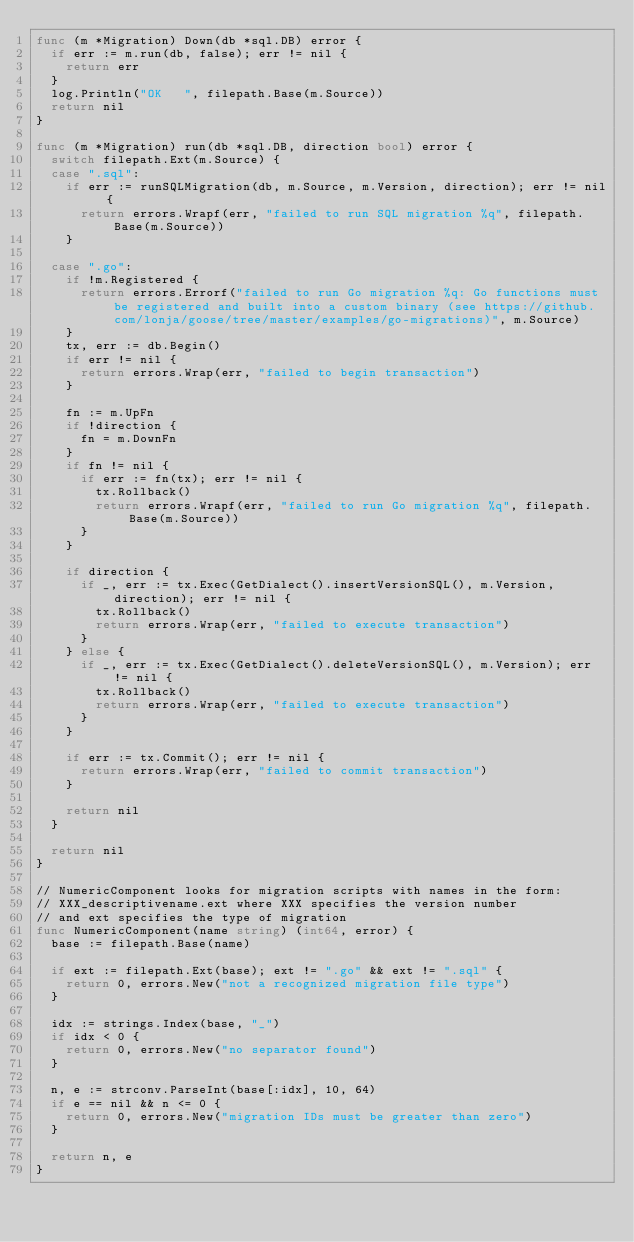Convert code to text. <code><loc_0><loc_0><loc_500><loc_500><_Go_>func (m *Migration) Down(db *sql.DB) error {
	if err := m.run(db, false); err != nil {
		return err
	}
	log.Println("OK   ", filepath.Base(m.Source))
	return nil
}

func (m *Migration) run(db *sql.DB, direction bool) error {
	switch filepath.Ext(m.Source) {
	case ".sql":
		if err := runSQLMigration(db, m.Source, m.Version, direction); err != nil {
			return errors.Wrapf(err, "failed to run SQL migration %q", filepath.Base(m.Source))
		}

	case ".go":
		if !m.Registered {
			return errors.Errorf("failed to run Go migration %q: Go functions must be registered and built into a custom binary (see https://github.com/lonja/goose/tree/master/examples/go-migrations)", m.Source)
		}
		tx, err := db.Begin()
		if err != nil {
			return errors.Wrap(err, "failed to begin transaction")
		}

		fn := m.UpFn
		if !direction {
			fn = m.DownFn
		}
		if fn != nil {
			if err := fn(tx); err != nil {
				tx.Rollback()
				return errors.Wrapf(err, "failed to run Go migration %q", filepath.Base(m.Source))
			}
		}

		if direction {
			if _, err := tx.Exec(GetDialect().insertVersionSQL(), m.Version, direction); err != nil {
				tx.Rollback()
				return errors.Wrap(err, "failed to execute transaction")
			}
		} else {
			if _, err := tx.Exec(GetDialect().deleteVersionSQL(), m.Version); err != nil {
				tx.Rollback()
				return errors.Wrap(err, "failed to execute transaction")
			}
		}

		if err := tx.Commit(); err != nil {
			return errors.Wrap(err, "failed to commit transaction")
		}

		return nil
	}

	return nil
}

// NumericComponent looks for migration scripts with names in the form:
// XXX_descriptivename.ext where XXX specifies the version number
// and ext specifies the type of migration
func NumericComponent(name string) (int64, error) {
	base := filepath.Base(name)

	if ext := filepath.Ext(base); ext != ".go" && ext != ".sql" {
		return 0, errors.New("not a recognized migration file type")
	}

	idx := strings.Index(base, "_")
	if idx < 0 {
		return 0, errors.New("no separator found")
	}

	n, e := strconv.ParseInt(base[:idx], 10, 64)
	if e == nil && n <= 0 {
		return 0, errors.New("migration IDs must be greater than zero")
	}

	return n, e
}
</code> 